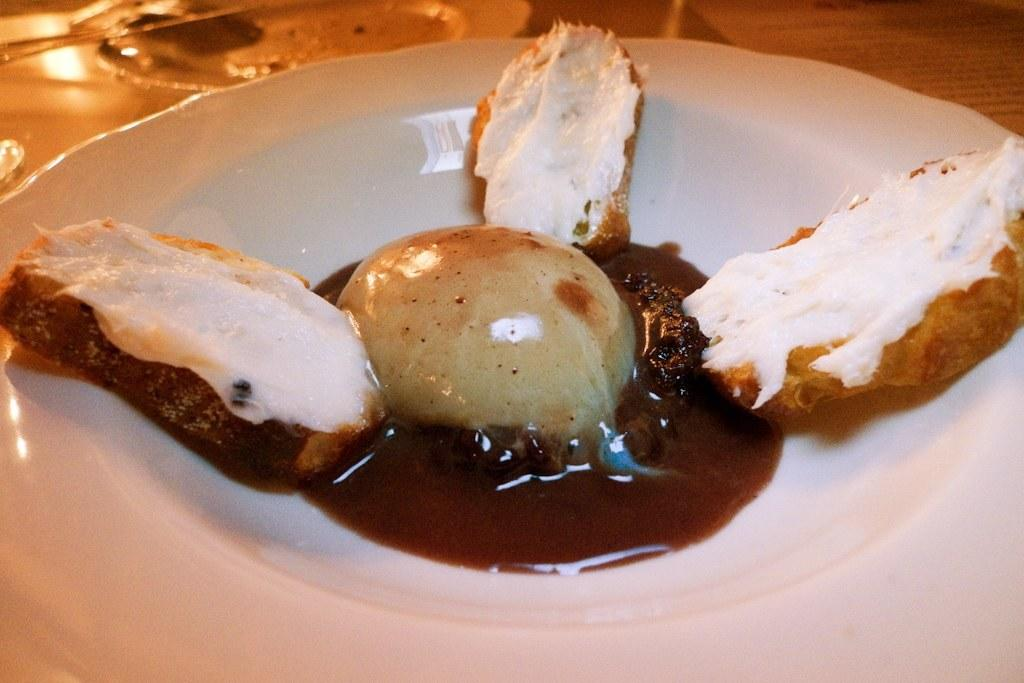What type of food item is visible in the image? There is a toast in the image. What is on top of the toast? Cream is present on the toast. Is there anything else on the toast besides the cream? Yes, there is a food item in the middle of the toast. How many goldfish are swimming in the cream on the toast? There are no goldfish present in the image; the cream is on a toast with a food item in the middle. 